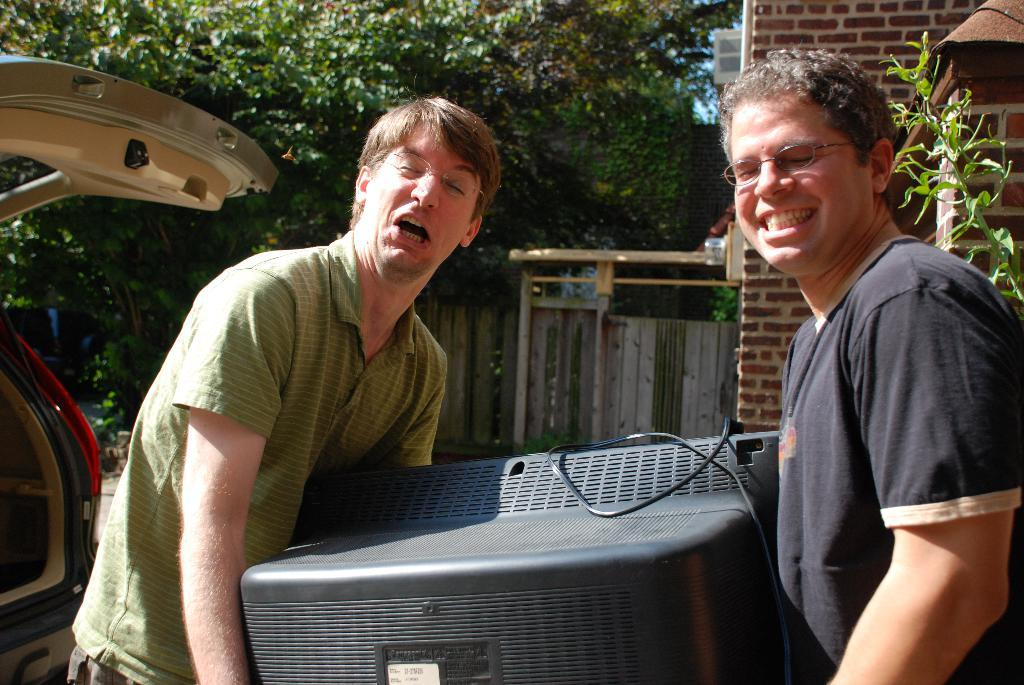How many people are present in the image? There are two people in the image. What are the people holding in the image? The people are holding a television. What type of vehicle is visible in the image? There is a car in the image. What type of vegetation can be seen in the image? There are trees in the image. What type of structure is visible in the image? There is a brick wall in the image. Can you see a crown on the head of one of the people in the image? No, there is no crown visible on the head of either person in the image. What type of kitchen appliance is present in the image? There is no kitchen appliance, such as a kettle, present in the image. 